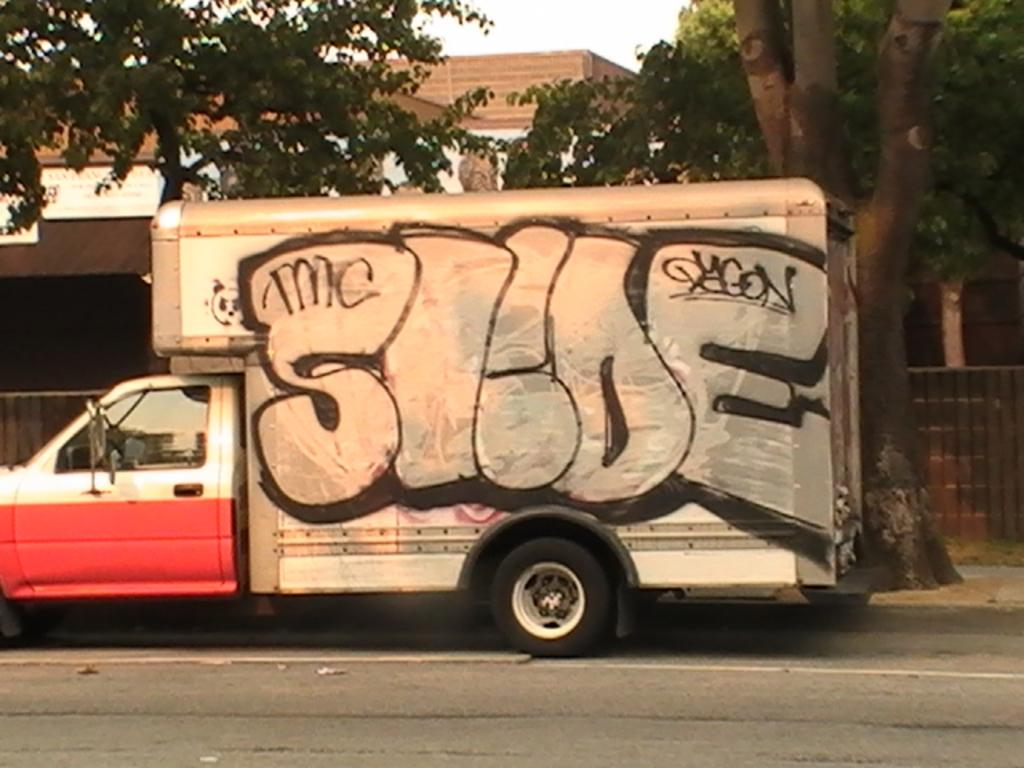What is happening on the road in the image? There is a vehicle passing on the road in the image. What can be seen in the distance behind the road? There are buildings, trees, and the sky visible in the background of the image. What type of dress is the quarter wearing in the image? There is no quarter or dress present in the image. Where is the bedroom located in the image? There is no bedroom present in the image. 